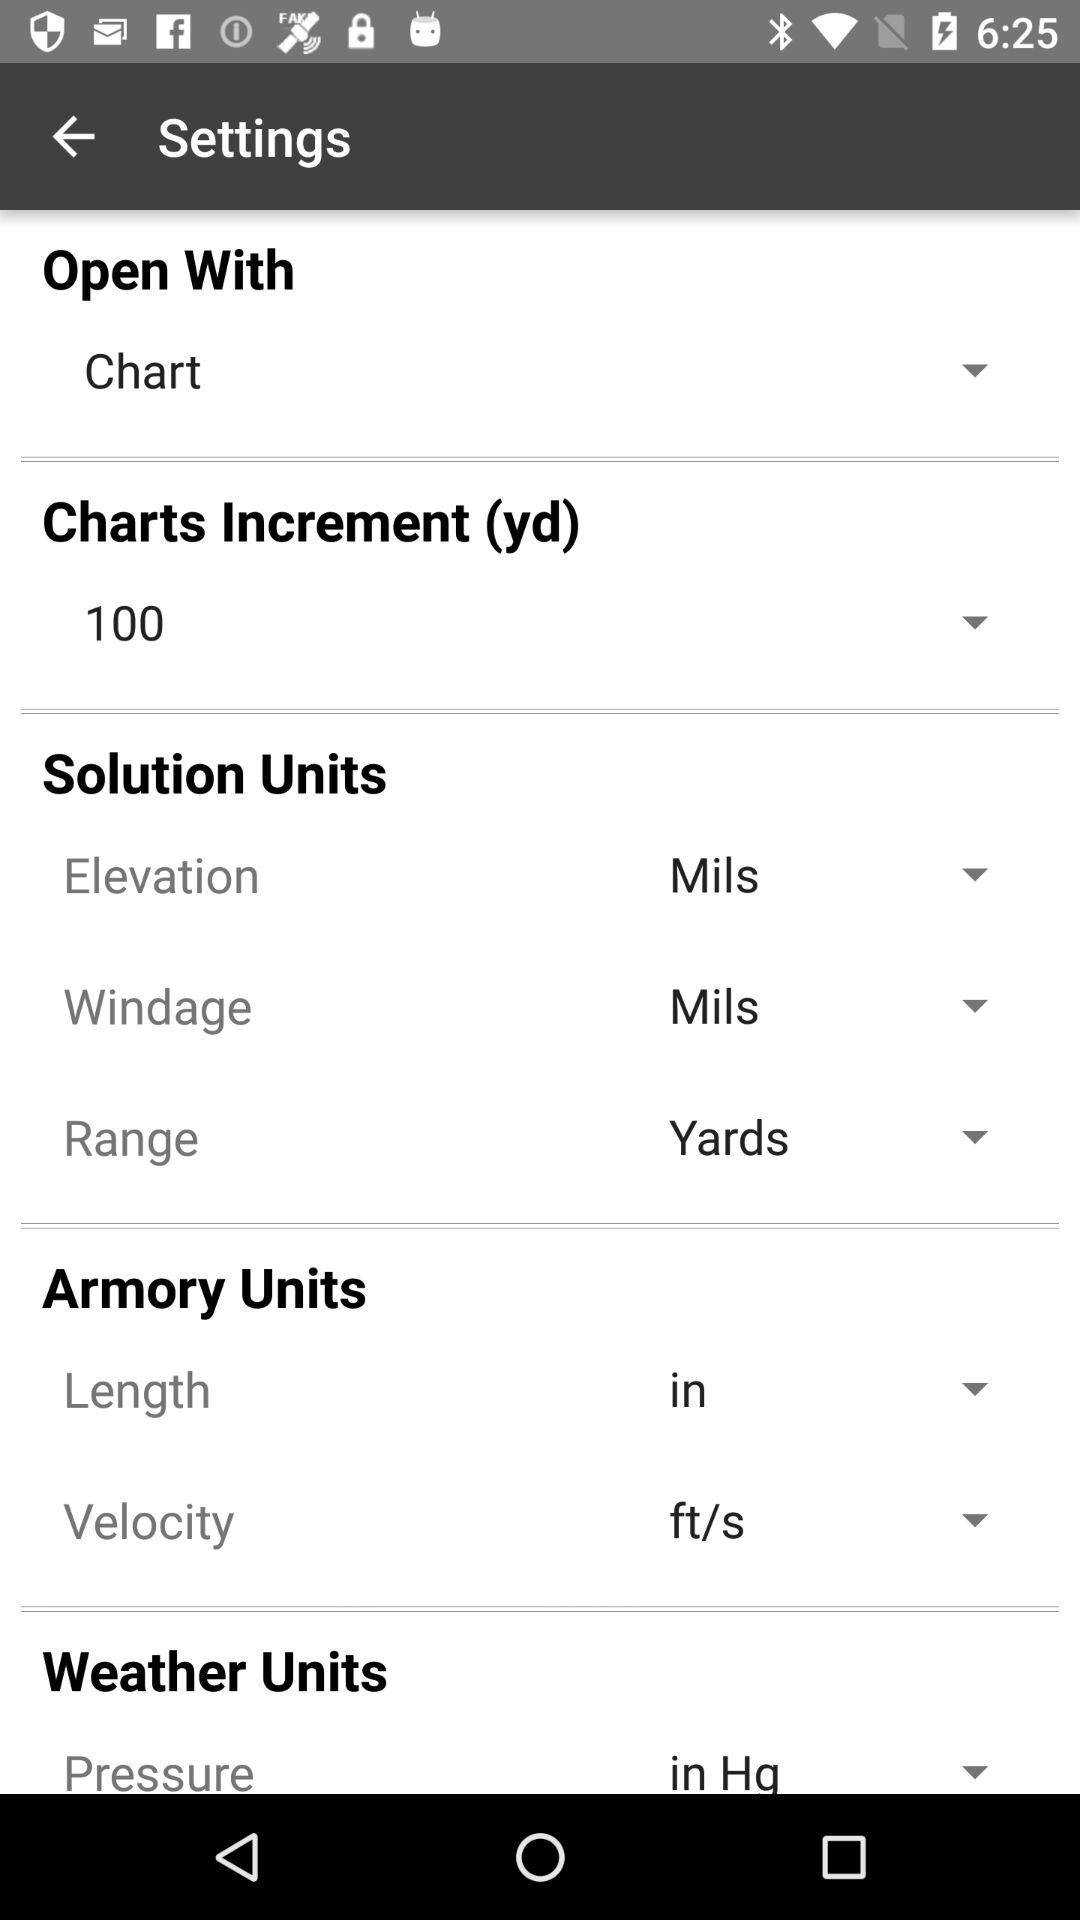What is the selected unit for Range? The selected unit for the range is "Yards". 